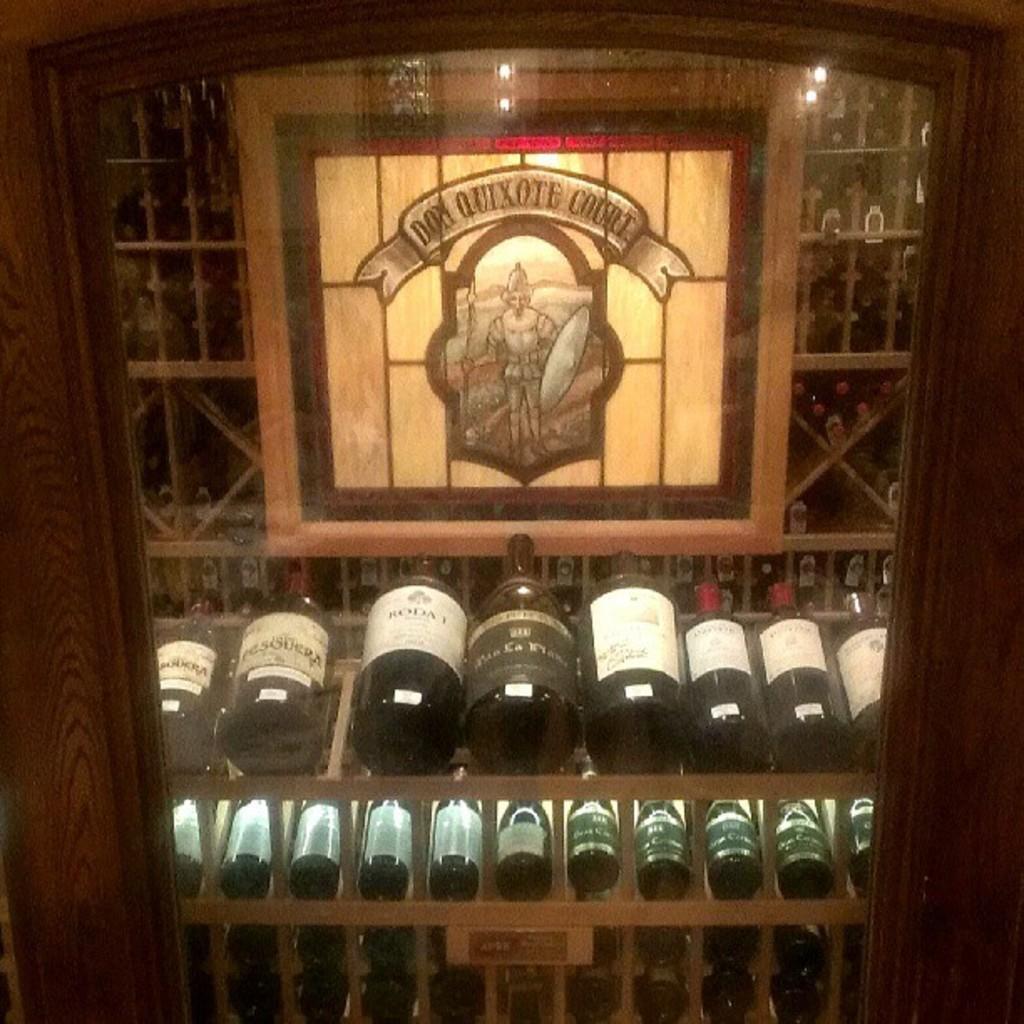In one or two sentences, can you explain what this image depicts? In this picture we can see some bottles in the racks and behind the bottles there is a logo on an object. In front of the bottles there is a glass. 